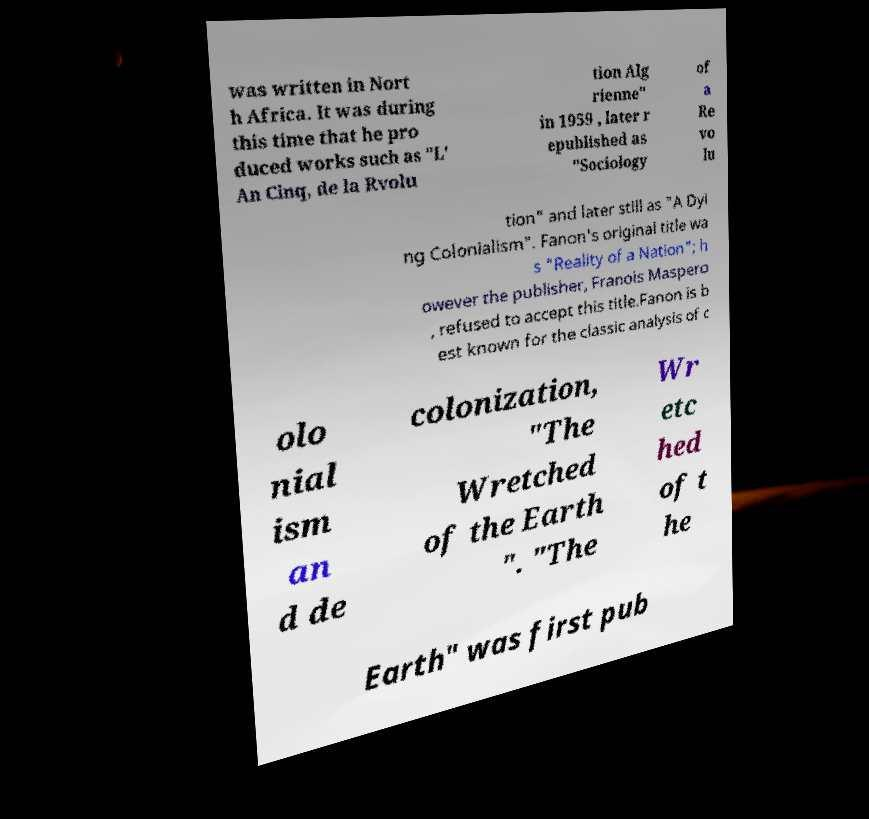Can you accurately transcribe the text from the provided image for me? was written in Nort h Africa. It was during this time that he pro duced works such as "L' An Cinq, de la Rvolu tion Alg rienne" in 1959 , later r epublished as "Sociology of a Re vo lu tion" and later still as "A Dyi ng Colonialism". Fanon's original title wa s "Reality of a Nation"; h owever the publisher, Franois Maspero , refused to accept this title.Fanon is b est known for the classic analysis of c olo nial ism an d de colonization, "The Wretched of the Earth ". "The Wr etc hed of t he Earth" was first pub 